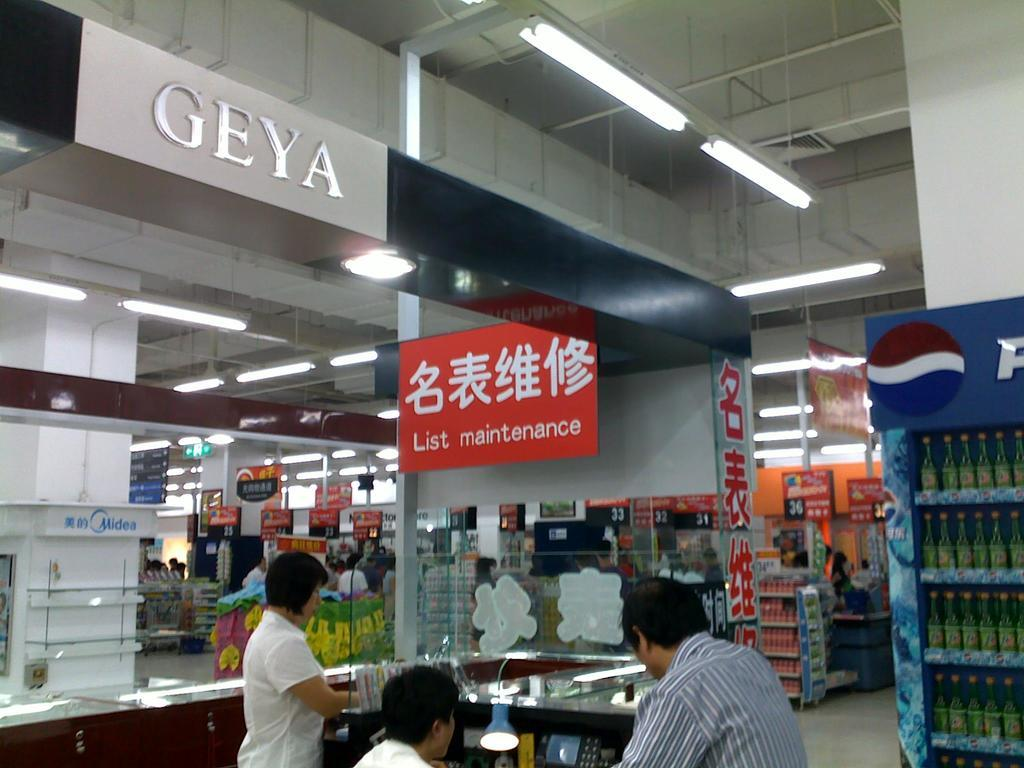Where is the setting of the image? The image is inside a building. Who or what can be seen in the image? There are people in the image. What can be seen illuminating the scene? There are lights in the image. What type of electronic device is present in the image? There is an iPhone in the image. What type of containers are visible in the image? There are bottles in the image. What type of writing surface is present in the image? There are boards in the image. What type of structure is present in the image? There is a wall in the image. What type of furniture is present in the image? There is a table in the image. What other objects can be seen in the image? There are other objects in the image. Can you see any rifles in the image? No, there are no rifles present in the image. What type of utensil is being used to eat a meal in the image? There is no meal or utensil visible in the image. Is the image taken inside a cave? No, the image is taken inside a building, not a cave. 